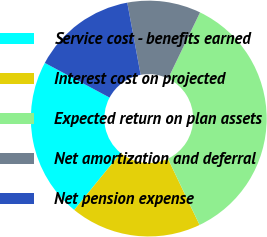Convert chart to OTSL. <chart><loc_0><loc_0><loc_500><loc_500><pie_chart><fcel>Service cost - benefits earned<fcel>Interest cost on projected<fcel>Expected return on plan assets<fcel>Net amortization and deferral<fcel>Net pension expense<nl><fcel>21.93%<fcel>17.98%<fcel>35.74%<fcel>10.08%<fcel>14.26%<nl></chart> 